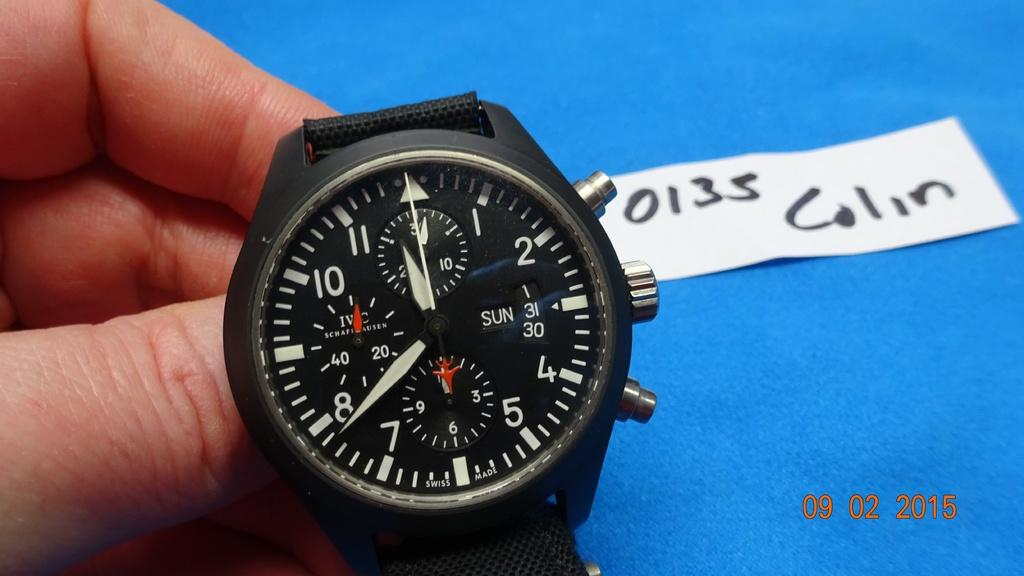<image>
Provide a brief description of the given image. Colin's black colored wristwatch repair has been completed. 